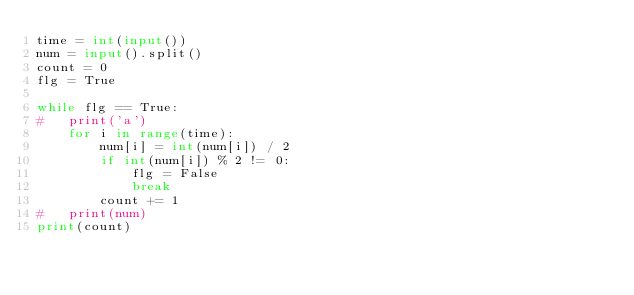Convert code to text. <code><loc_0><loc_0><loc_500><loc_500><_Python_>time = int(input())
num = input().split()
count = 0
flg = True

while flg == True:
#	print('a')
	for i in range(time):
		num[i] = int(num[i]) / 2
		if int(num[i]) % 2 != 0:
			flg = False
			break
		count += 1
#	print(num)
print(count)</code> 